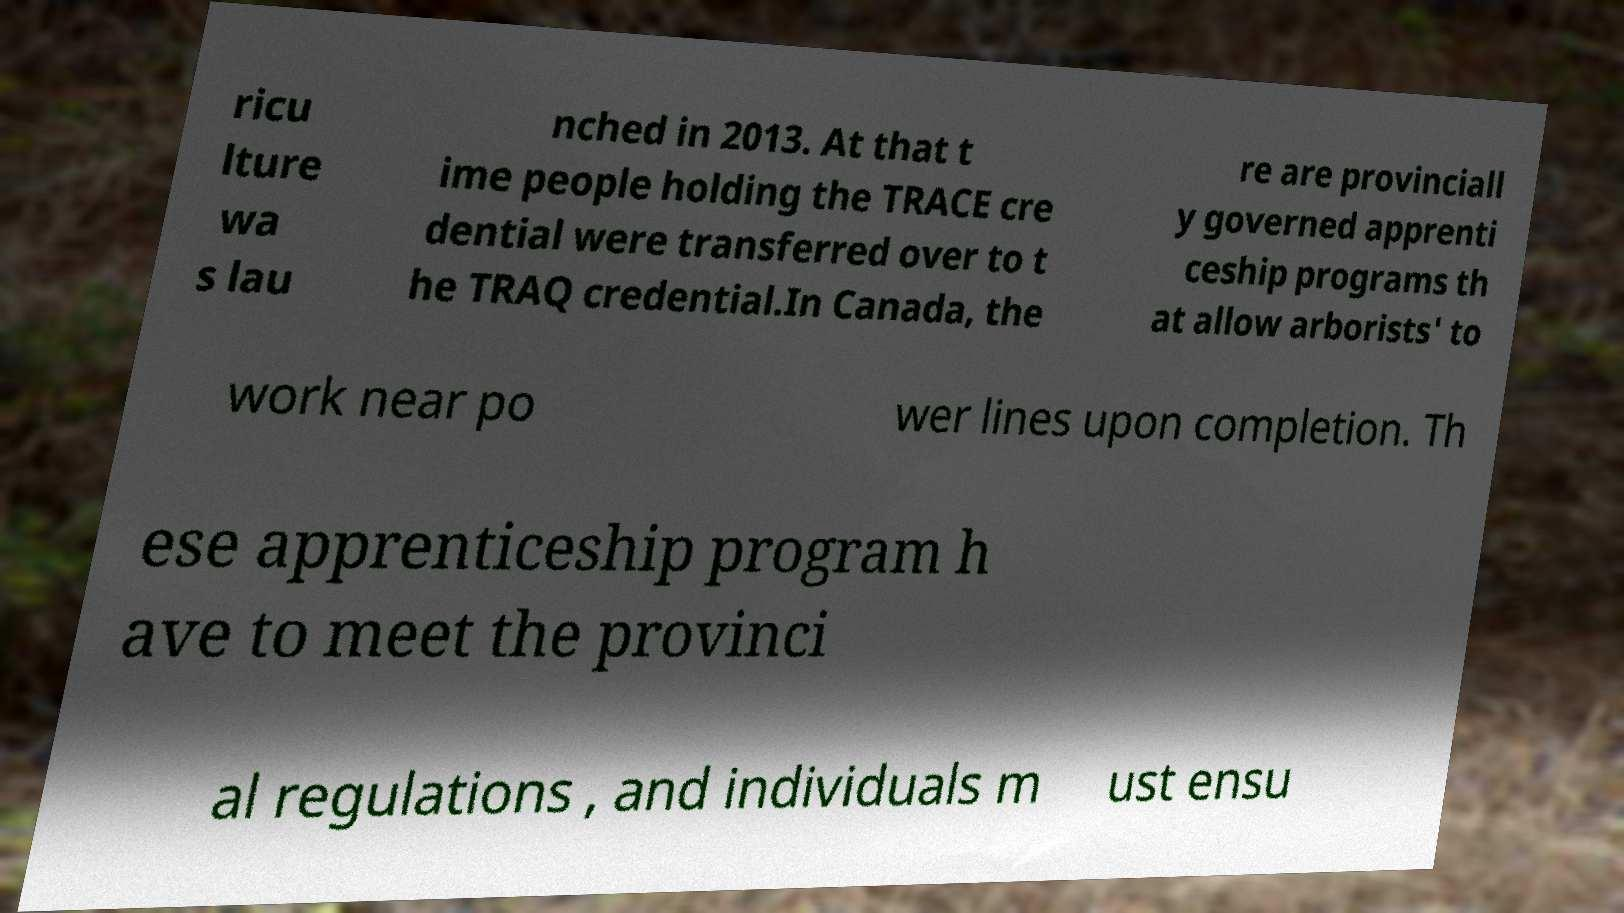Can you accurately transcribe the text from the provided image for me? ricu lture wa s lau nched in 2013. At that t ime people holding the TRACE cre dential were transferred over to t he TRAQ credential.In Canada, the re are provinciall y governed apprenti ceship programs th at allow arborists' to work near po wer lines upon completion. Th ese apprenticeship program h ave to meet the provinci al regulations , and individuals m ust ensu 